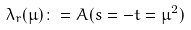<formula> <loc_0><loc_0><loc_500><loc_500>\lambda _ { r } ( \mu ) \colon = A ( s = - t = \mu ^ { 2 } )</formula> 